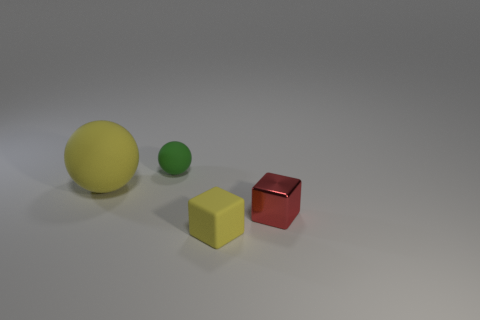Add 3 small purple cubes. How many objects exist? 7 Subtract 1 green spheres. How many objects are left? 3 Subtract all large purple things. Subtract all tiny yellow rubber blocks. How many objects are left? 3 Add 1 large yellow things. How many large yellow things are left? 2 Add 1 large matte objects. How many large matte objects exist? 2 